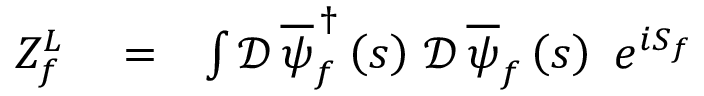<formula> <loc_0><loc_0><loc_500><loc_500>\begin{array} { r l r } { Z _ { f } ^ { L } } & = } & { \int \mathcal { D } \, \overline { \psi } _ { f } ^ { \, \dag } \left ( s \right ) \, \mathcal { D } \, \overline { \psi } _ { f } \left ( s \right ) \, e ^ { i S _ { f } } } \end{array}</formula> 